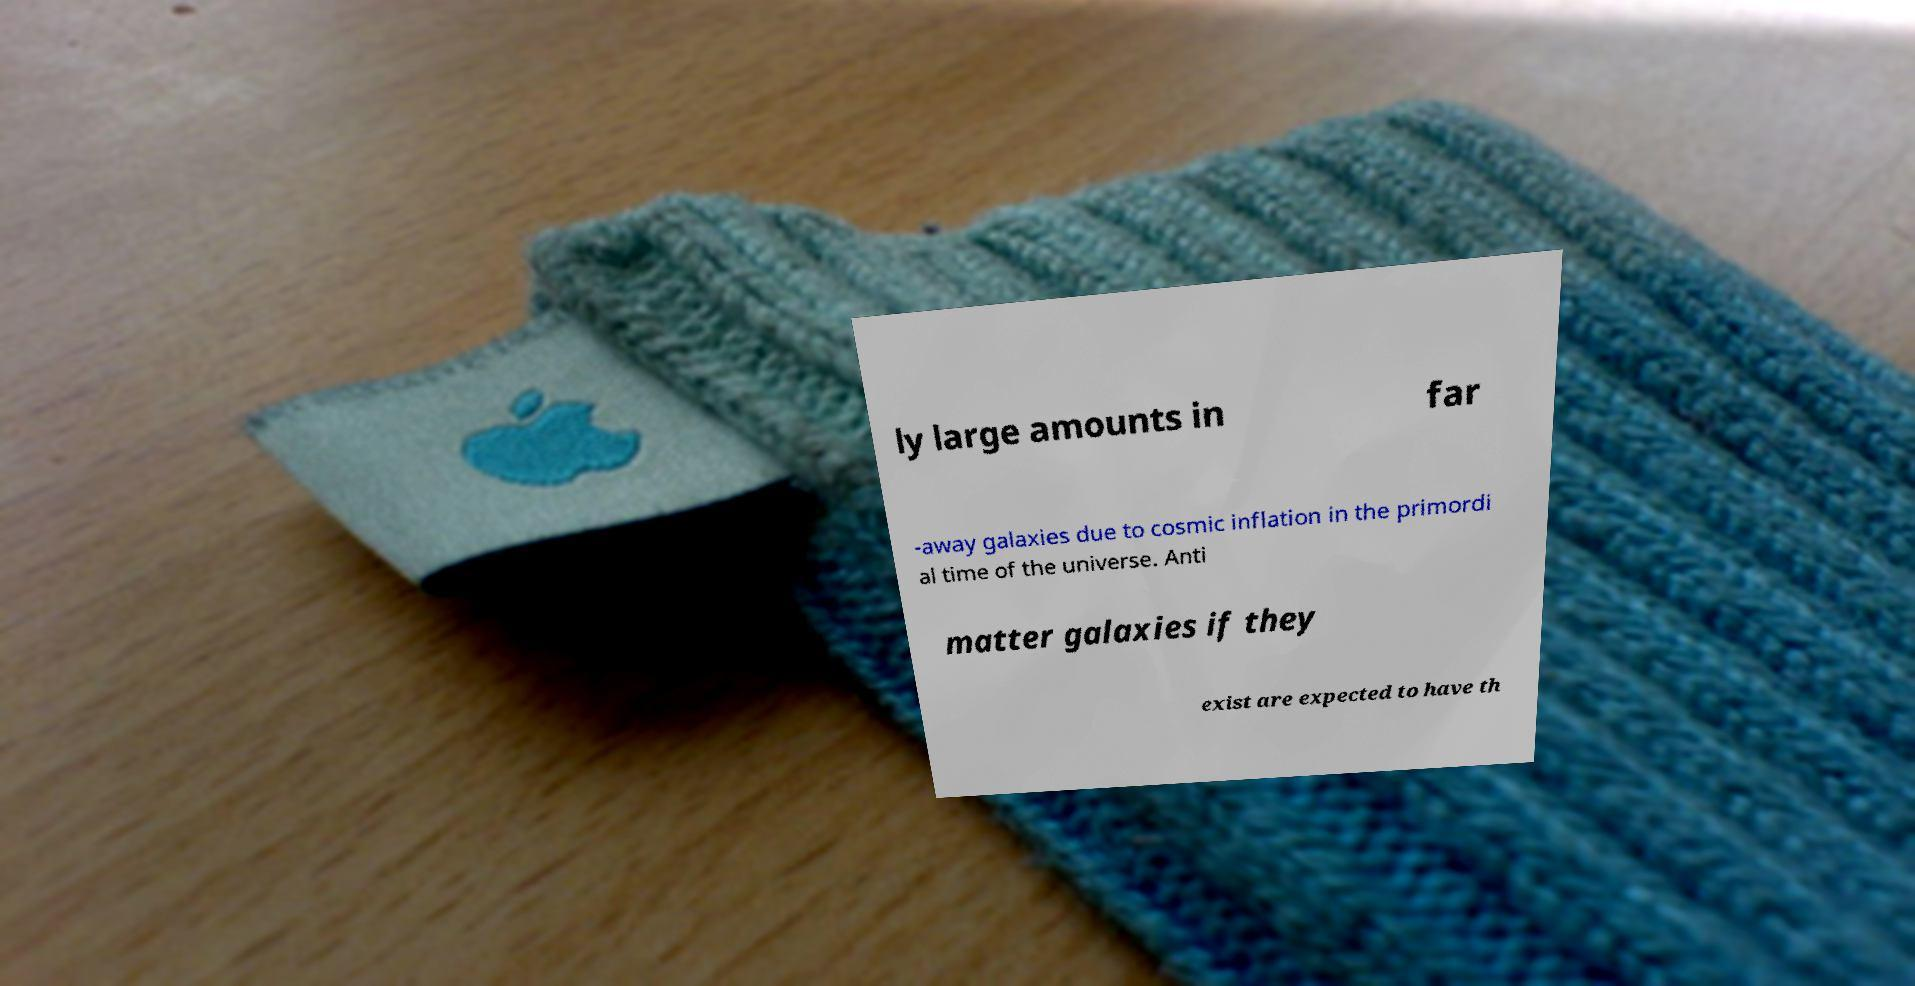I need the written content from this picture converted into text. Can you do that? ly large amounts in far -away galaxies due to cosmic inflation in the primordi al time of the universe. Anti matter galaxies if they exist are expected to have th 